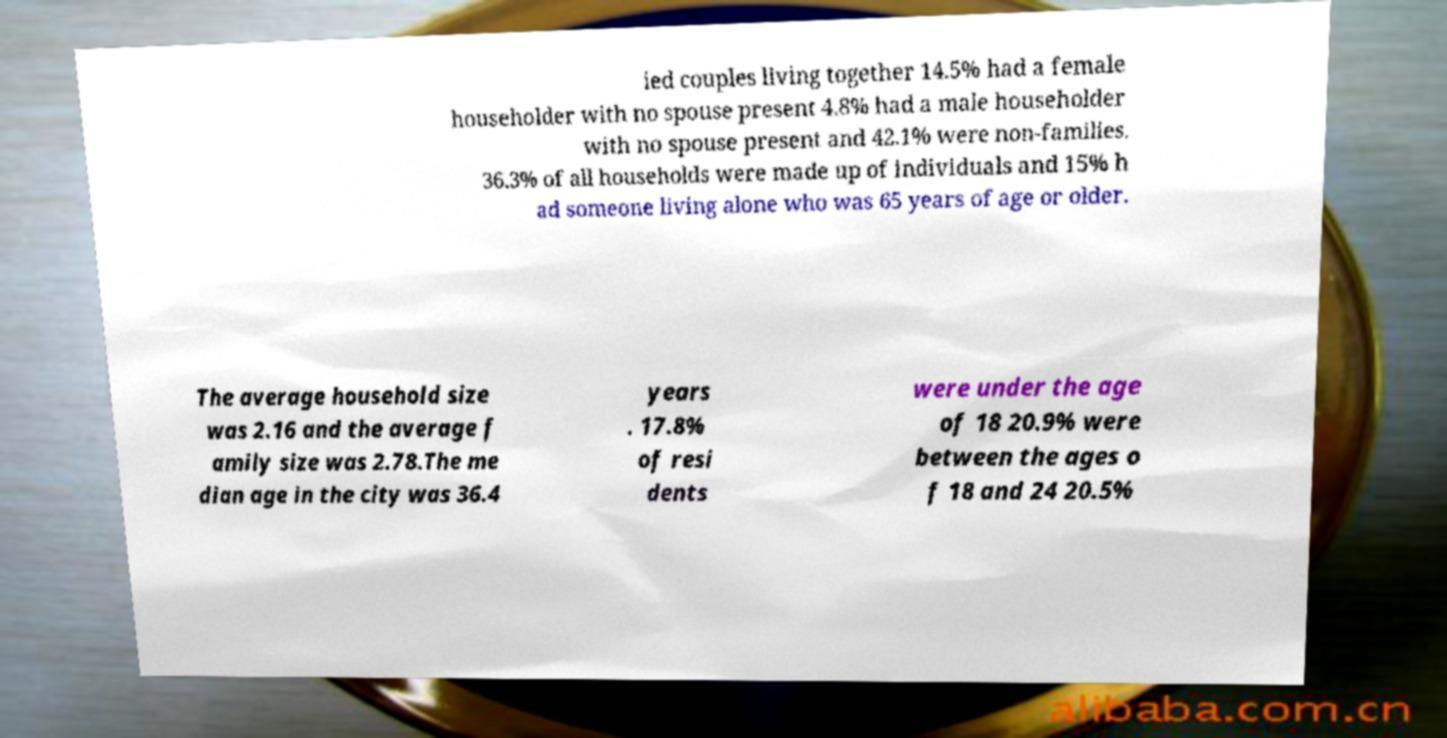Could you assist in decoding the text presented in this image and type it out clearly? ied couples living together 14.5% had a female householder with no spouse present 4.8% had a male householder with no spouse present and 42.1% were non-families. 36.3% of all households were made up of individuals and 15% h ad someone living alone who was 65 years of age or older. The average household size was 2.16 and the average f amily size was 2.78.The me dian age in the city was 36.4 years . 17.8% of resi dents were under the age of 18 20.9% were between the ages o f 18 and 24 20.5% 